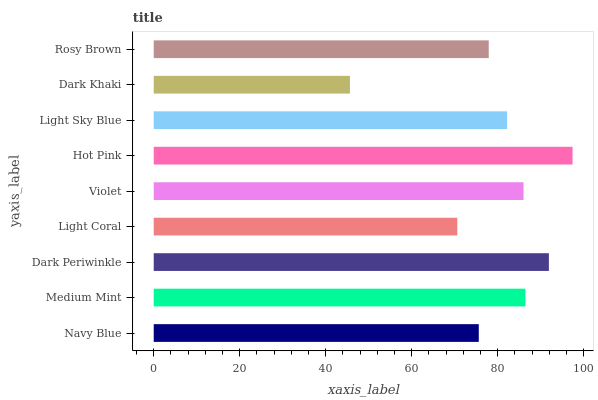Is Dark Khaki the minimum?
Answer yes or no. Yes. Is Hot Pink the maximum?
Answer yes or no. Yes. Is Medium Mint the minimum?
Answer yes or no. No. Is Medium Mint the maximum?
Answer yes or no. No. Is Medium Mint greater than Navy Blue?
Answer yes or no. Yes. Is Navy Blue less than Medium Mint?
Answer yes or no. Yes. Is Navy Blue greater than Medium Mint?
Answer yes or no. No. Is Medium Mint less than Navy Blue?
Answer yes or no. No. Is Light Sky Blue the high median?
Answer yes or no. Yes. Is Light Sky Blue the low median?
Answer yes or no. Yes. Is Violet the high median?
Answer yes or no. No. Is Navy Blue the low median?
Answer yes or no. No. 